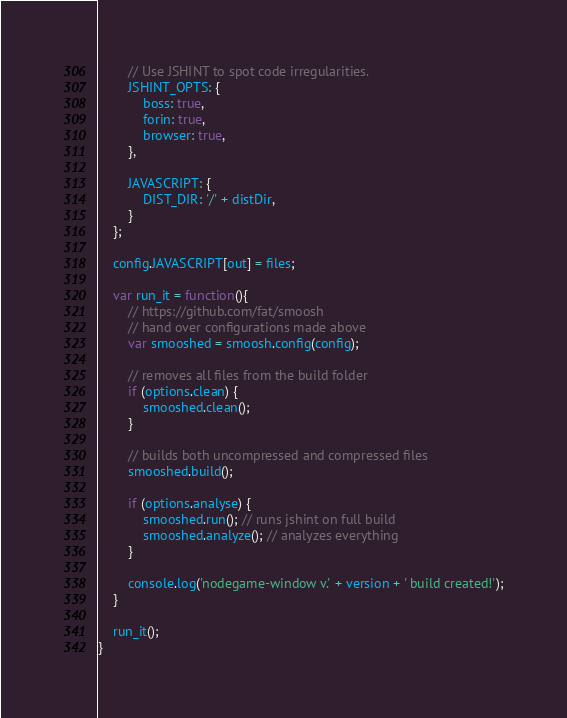Convert code to text. <code><loc_0><loc_0><loc_500><loc_500><_JavaScript_>
        // Use JSHINT to spot code irregularities.
        JSHINT_OPTS: {
            boss: true,
            forin: true,
            browser: true,
        },

        JAVASCRIPT: {
            DIST_DIR: '/' + distDir,
        }
    };

    config.JAVASCRIPT[out] = files;

    var run_it = function(){
        // https://github.com/fat/smoosh
        // hand over configurations made above
        var smooshed = smoosh.config(config);

        // removes all files from the build folder
        if (options.clean) {
            smooshed.clean();
        }

        // builds both uncompressed and compressed files
        smooshed.build();

        if (options.analyse) {
            smooshed.run(); // runs jshint on full build
            smooshed.analyze(); // analyzes everything
        }

        console.log('nodegame-window v.' + version + ' build created!');
    }

    run_it();
}
</code> 